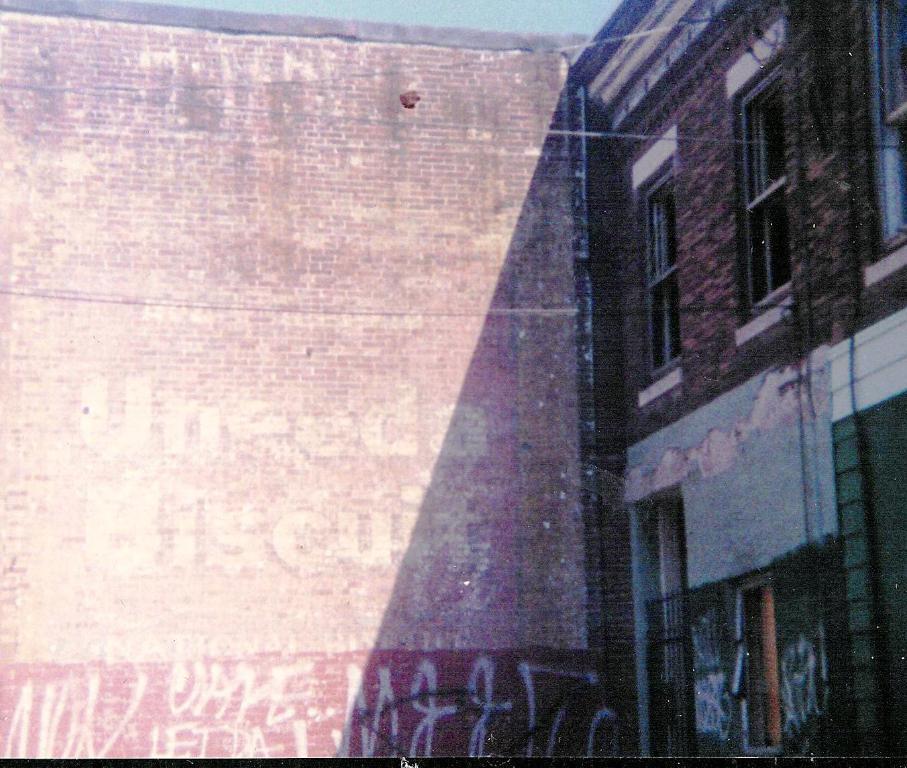How would you summarize this image in a sentence or two? In this picture we can see some text on a brick wall. There is a building and a few windows on it. 